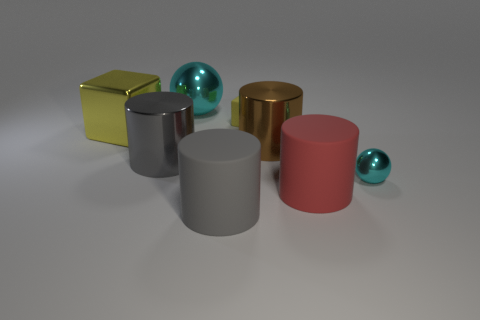What size is the yellow object that is on the left side of the ball to the left of the matte object right of the small matte object?
Ensure brevity in your answer.  Large. Do the rubber cube and the cyan metallic sphere that is behind the tiny cyan metal ball have the same size?
Your answer should be compact. No. Is the number of large yellow metallic objects that are to the left of the red cylinder less than the number of small cyan shiny things?
Ensure brevity in your answer.  No. How many big matte cylinders are the same color as the small rubber block?
Give a very brief answer. 0. Are there fewer cyan matte cylinders than tiny yellow matte blocks?
Provide a short and direct response. Yes. Is the material of the small yellow cube the same as the big cyan thing?
Your answer should be compact. No. How many other things are there of the same size as the red rubber cylinder?
Ensure brevity in your answer.  5. The rubber thing behind the cyan metallic ball in front of the big cube is what color?
Your response must be concise. Yellow. What number of other objects are the same shape as the brown shiny thing?
Your answer should be very brief. 3. Are there any large cubes made of the same material as the big ball?
Offer a very short reply. Yes. 